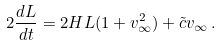<formula> <loc_0><loc_0><loc_500><loc_500>2 \frac { d L } { d t } = 2 H L ( 1 + v _ { \infty } ^ { 2 } ) + { \tilde { c } } v _ { \infty } \, .</formula> 